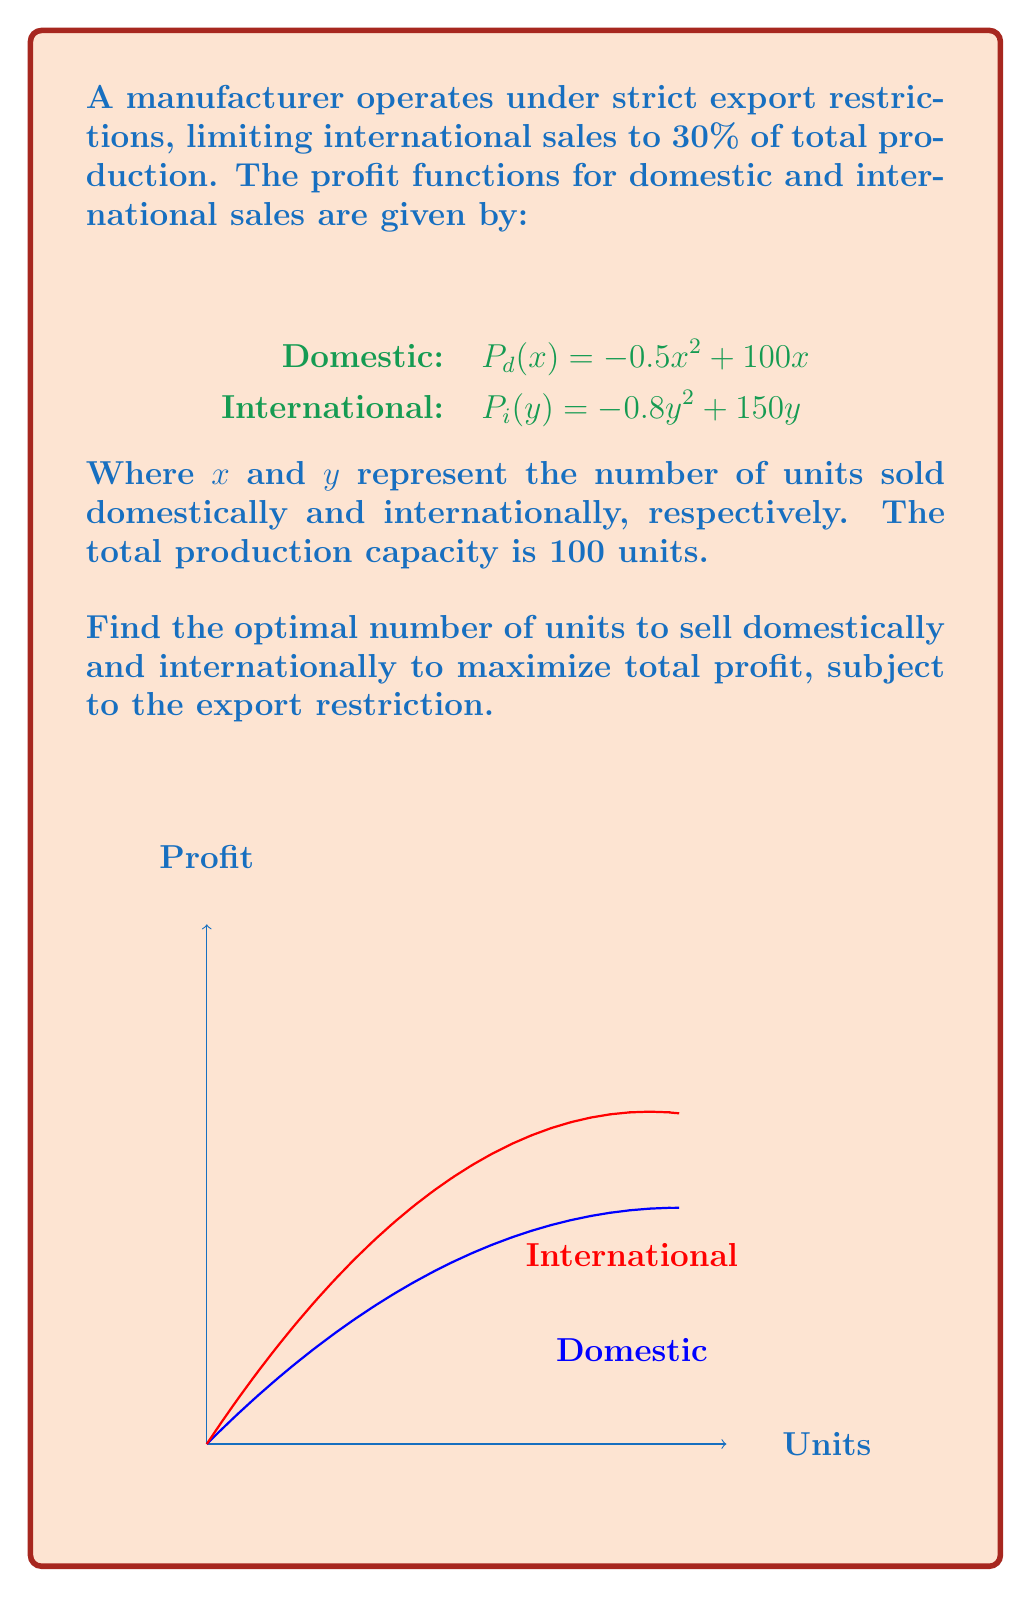Show me your answer to this math problem. Let's approach this step-by-step:

1) Given the export restriction, we can express $y$ in terms of $x$:
   $y = \frac{30x}{70}$ (since $y$ is 30% of total production, and $x$ is 70%)

2) The total profit function $P(x)$ is the sum of domestic and international profits:
   $$P(x) = P_d(x) + P_i(y) = (-0.5x^2 + 100x) + (-0.8(\frac{30x}{70})^2 + 150(\frac{30x}{70}))$$

3) Simplify the equation:
   $$P(x) = -0.5x^2 + 100x - 0.8(\frac{900x^2}{4900}) + \frac{4500x}{70}$$
   $$P(x) = -0.5x^2 + 100x - \frac{720x^2}{4900} + \frac{4500x}{70}$$
   $$P(x) = -0.5x^2 - 0.147x^2 + 100x + 64.29x$$
   $$P(x) = -0.647x^2 + 164.29x$$

4) To find the maximum profit, we differentiate $P(x)$ and set it to zero:
   $$\frac{dP}{dx} = -1.294x + 164.29 = 0$$

5) Solve for $x$:
   $$x = \frac{164.29}{1.294} \approx 127$$

6) However, our total production capacity is 100 units. So, we use $x = 100$.

7) Calculate $y$:
   $$y = \frac{30(100)}{70} \approx 42.86$$

8) Round down to ensure we don't exceed the export restriction:
   $x = 100$, $y = 42$
Answer: Domestic: 100 units, International: 42 units 